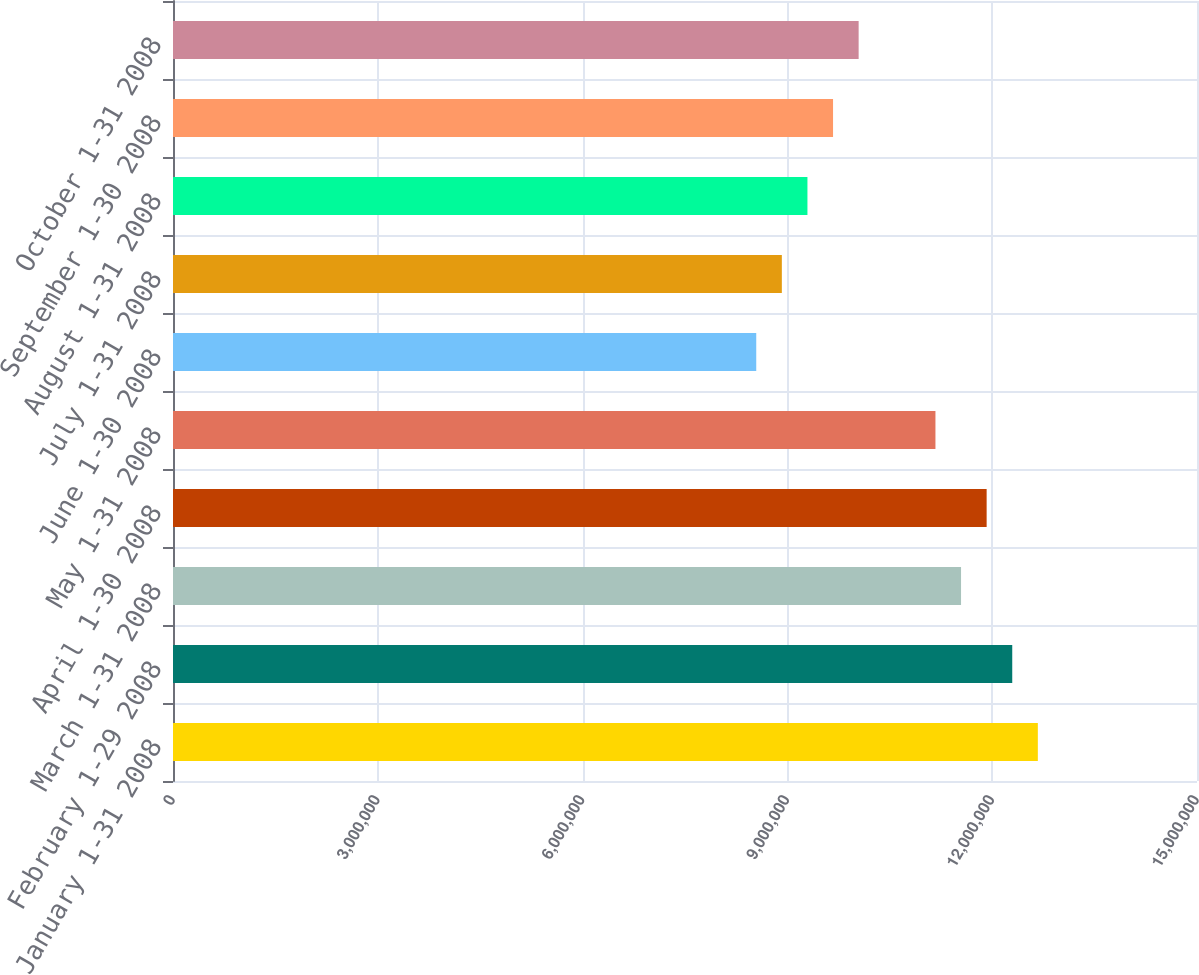Convert chart to OTSL. <chart><loc_0><loc_0><loc_500><loc_500><bar_chart><fcel>January 1-31 2008<fcel>February 1-29 2008<fcel>March 1-31 2008<fcel>April 1-30 2008<fcel>May 1-31 2008<fcel>June 1-30 2008<fcel>July 1-31 2008<fcel>August 1-31 2008<fcel>September 1-30 2008<fcel>October 1-31 2008<nl><fcel>1.26686e+07<fcel>1.22936e+07<fcel>1.15436e+07<fcel>1.19186e+07<fcel>1.11686e+07<fcel>8.54361e+06<fcel>8.91861e+06<fcel>9.29361e+06<fcel>9.66861e+06<fcel>1.00436e+07<nl></chart> 